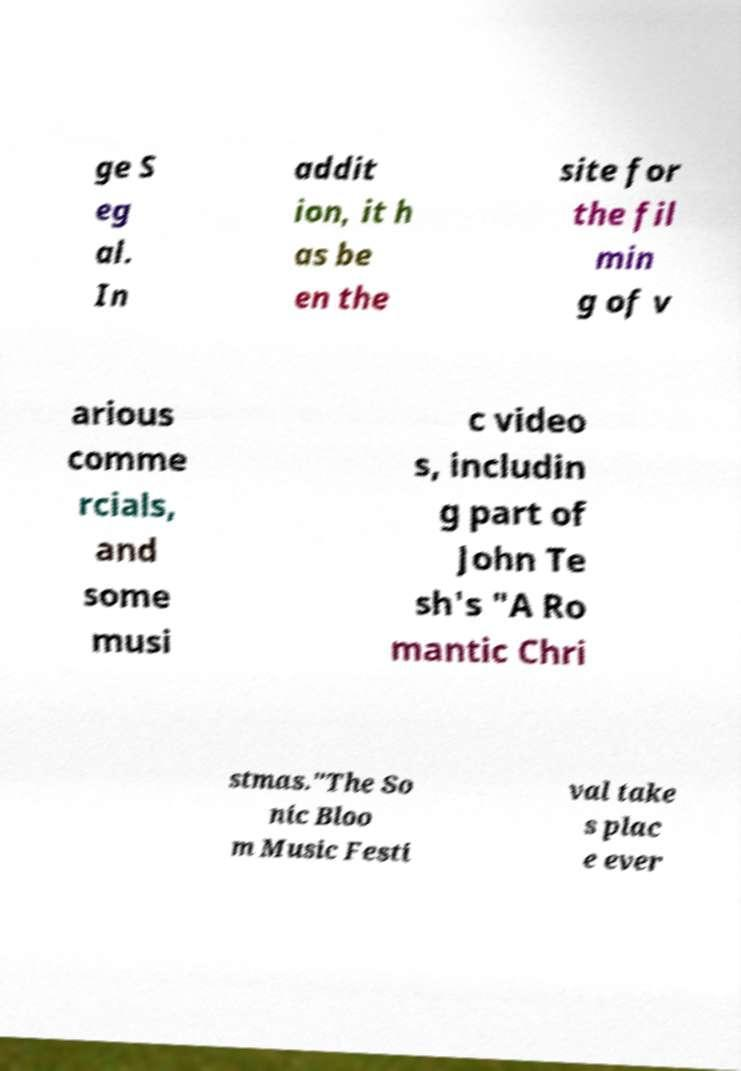Can you read and provide the text displayed in the image?This photo seems to have some interesting text. Can you extract and type it out for me? ge S eg al. In addit ion, it h as be en the site for the fil min g of v arious comme rcials, and some musi c video s, includin g part of John Te sh's "A Ro mantic Chri stmas."The So nic Bloo m Music Festi val take s plac e ever 